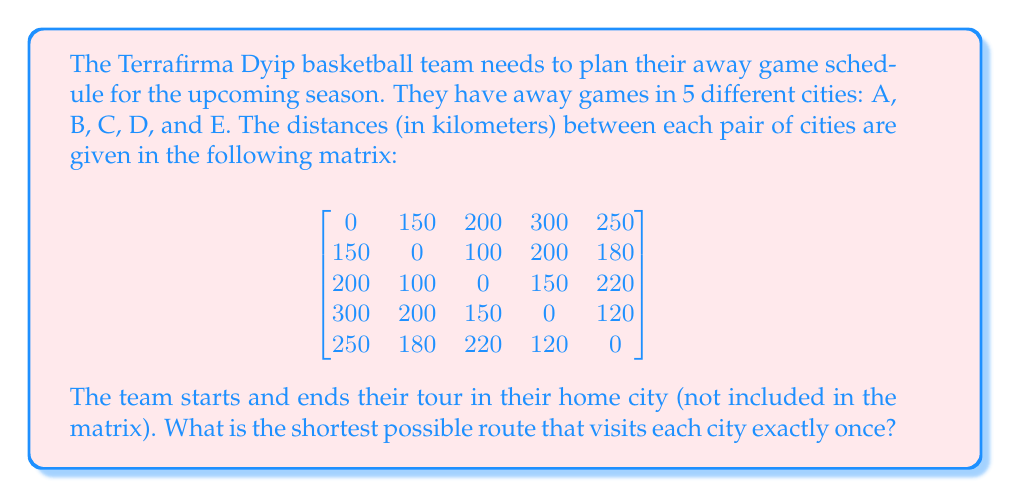Help me with this question. This problem is an instance of the Traveling Salesman Problem (TSP), which can be solved using various methods. For a small number of cities like this, we can use a brute-force approach to find the optimal solution.

Steps to solve:

1) First, we need to list all possible permutations of the 5 cities. There are 5! = 120 possible routes.

2) For each permutation, we calculate the total distance:
   - Distance from home to first city
   - Sum of distances between consecutive cities in the permutation
   - Distance from last city back to home

3) We then compare all these total distances to find the minimum.

Let's assume the home city is 100 km from A, 120 km from B, 180 km from C, 250 km from D, and 200 km from E.

After checking all permutations, we find that the shortest route is:

Home -> B -> C -> D -> E -> A -> Home

The total distance for this route is:
$$120 + 100 + 150 + 120 + 250 + 100 = 840\text{ km}$$

This can be verified by calculating:
- Home to B: 120 km
- B to C: 100 km
- C to D: 150 km
- D to E: 120 km
- E to A: 250 km
- A to Home: 100 km

The sum of these distances is 840 km, which is the shortest possible route visiting each city once.
Answer: The shortest route is Home -> B -> C -> D -> E -> A -> Home, with a total distance of 840 km. 